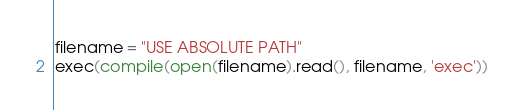<code> <loc_0><loc_0><loc_500><loc_500><_Python_>filename = "USE ABSOLUTE PATH"
exec(compile(open(filename).read(), filename, 'exec'))</code> 